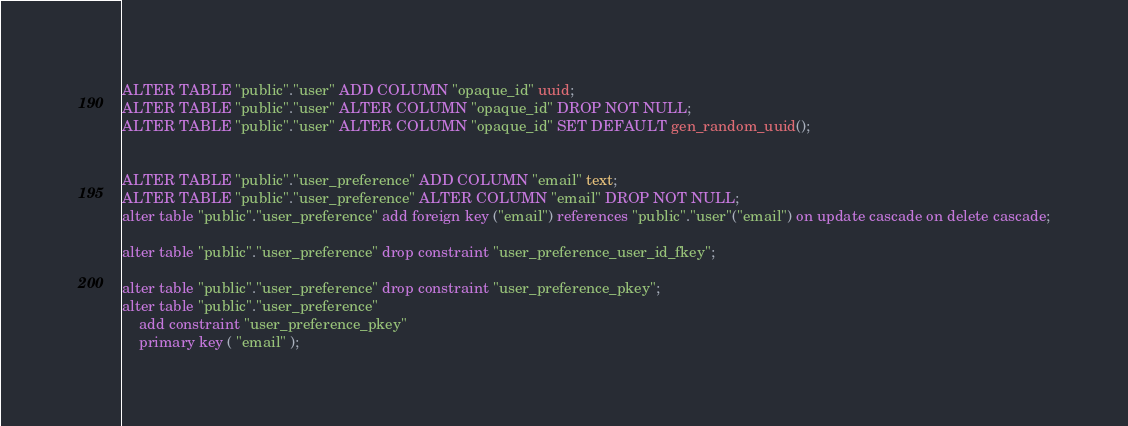Convert code to text. <code><loc_0><loc_0><loc_500><loc_500><_SQL_>ALTER TABLE "public"."user" ADD COLUMN "opaque_id" uuid;
ALTER TABLE "public"."user" ALTER COLUMN "opaque_id" DROP NOT NULL;
ALTER TABLE "public"."user" ALTER COLUMN "opaque_id" SET DEFAULT gen_random_uuid();


ALTER TABLE "public"."user_preference" ADD COLUMN "email" text;
ALTER TABLE "public"."user_preference" ALTER COLUMN "email" DROP NOT NULL;
alter table "public"."user_preference" add foreign key ("email") references "public"."user"("email") on update cascade on delete cascade;

alter table "public"."user_preference" drop constraint "user_preference_user_id_fkey";

alter table "public"."user_preference" drop constraint "user_preference_pkey";
alter table "public"."user_preference"
    add constraint "user_preference_pkey"
    primary key ( "email" );</code> 